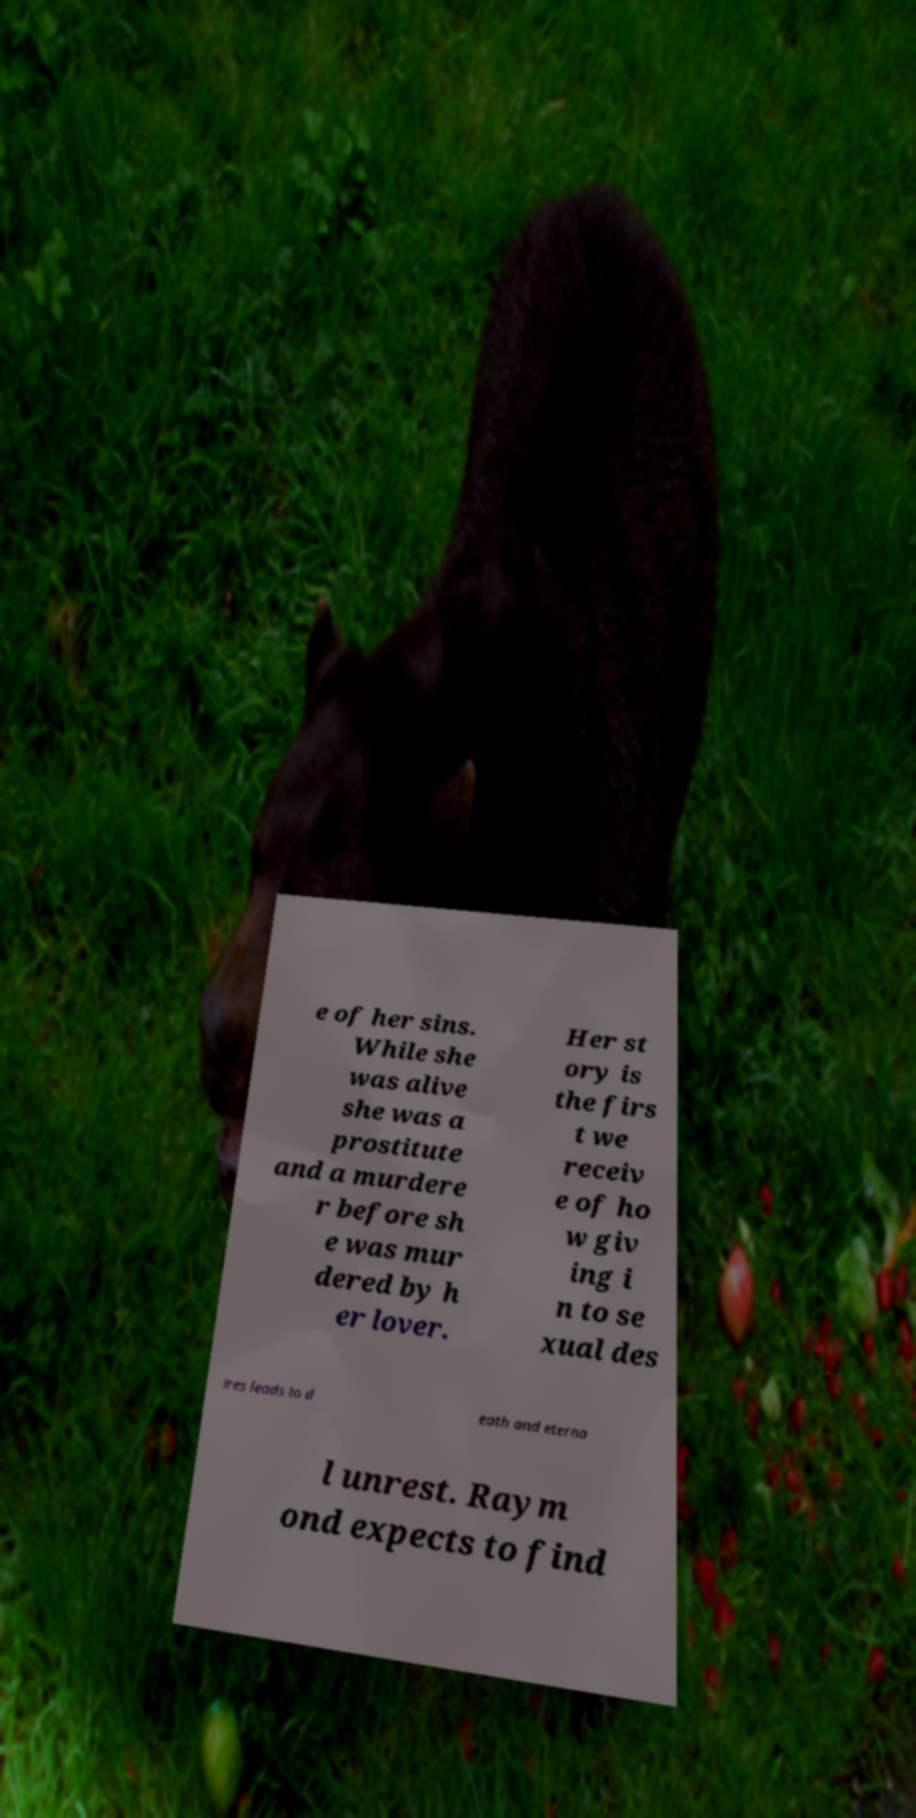There's text embedded in this image that I need extracted. Can you transcribe it verbatim? e of her sins. While she was alive she was a prostitute and a murdere r before sh e was mur dered by h er lover. Her st ory is the firs t we receiv e of ho w giv ing i n to se xual des ires leads to d eath and eterna l unrest. Raym ond expects to find 